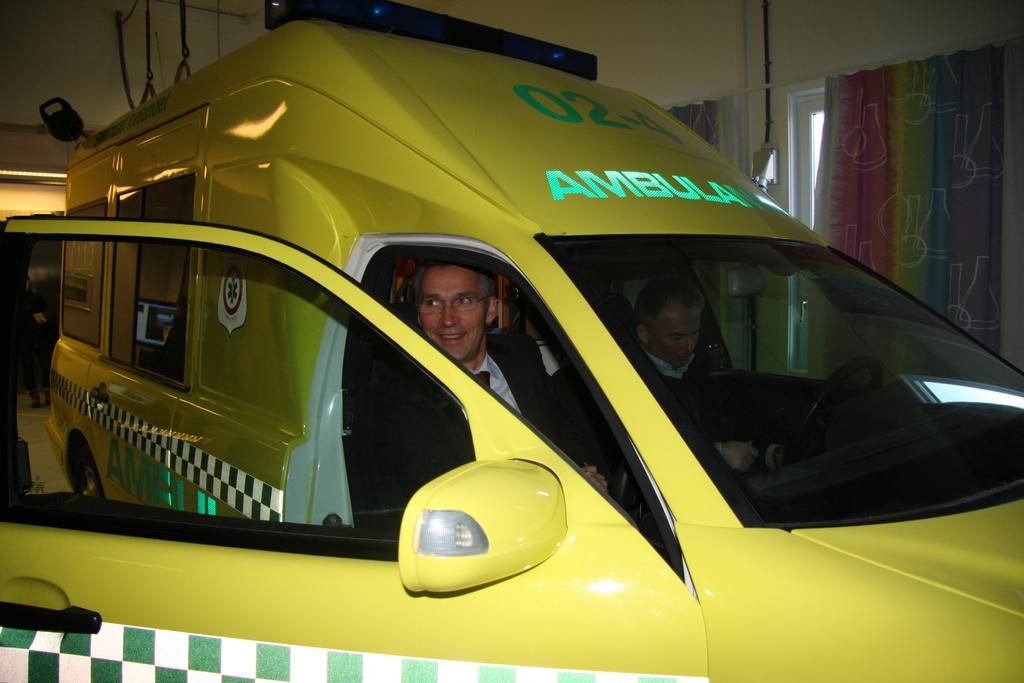<image>
Give a short and clear explanation of the subsequent image. A yellow Ambulance with the numbers 02-4 on it. 